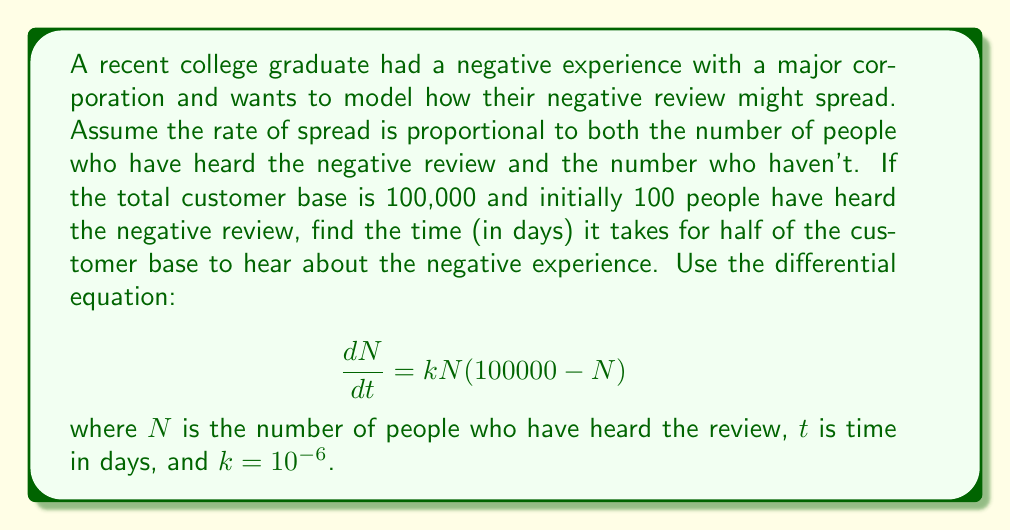Provide a solution to this math problem. 1) The given differential equation is a logistic growth model:
   $$\frac{dN}{dt} = kN(100000 - N)$$

2) The solution to this equation is:
   $$N(t) = \frac{100000}{1 + 999e^{-100000kt}}$$

3) We want to find $t$ when $N(t) = 50000$ (half of the customer base):
   $$50000 = \frac{100000}{1 + 999e^{-100000kt}}$$

4) Solve for $t$:
   $$1 + 999e^{-100000kt} = 2$$
   $$999e^{-100000kt} = 1$$
   $$e^{-100000kt} = \frac{1}{999}$$
   $$-100000kt = \ln(\frac{1}{999})$$
   $$t = -\frac{\ln(\frac{1}{999})}{100000k}$$

5) Substitute $k = 10^{-6}$:
   $$t = -\frac{\ln(\frac{1}{999})}{100000 \cdot 10^{-6}}$$
   $$t = -\frac{\ln(\frac{1}{999})}{0.1}$$
   $$t = 10\ln(999) \approx 68.99$$

6) Round to two decimal places: $t \approx 68.99$ days.
Answer: $68.99$ days 